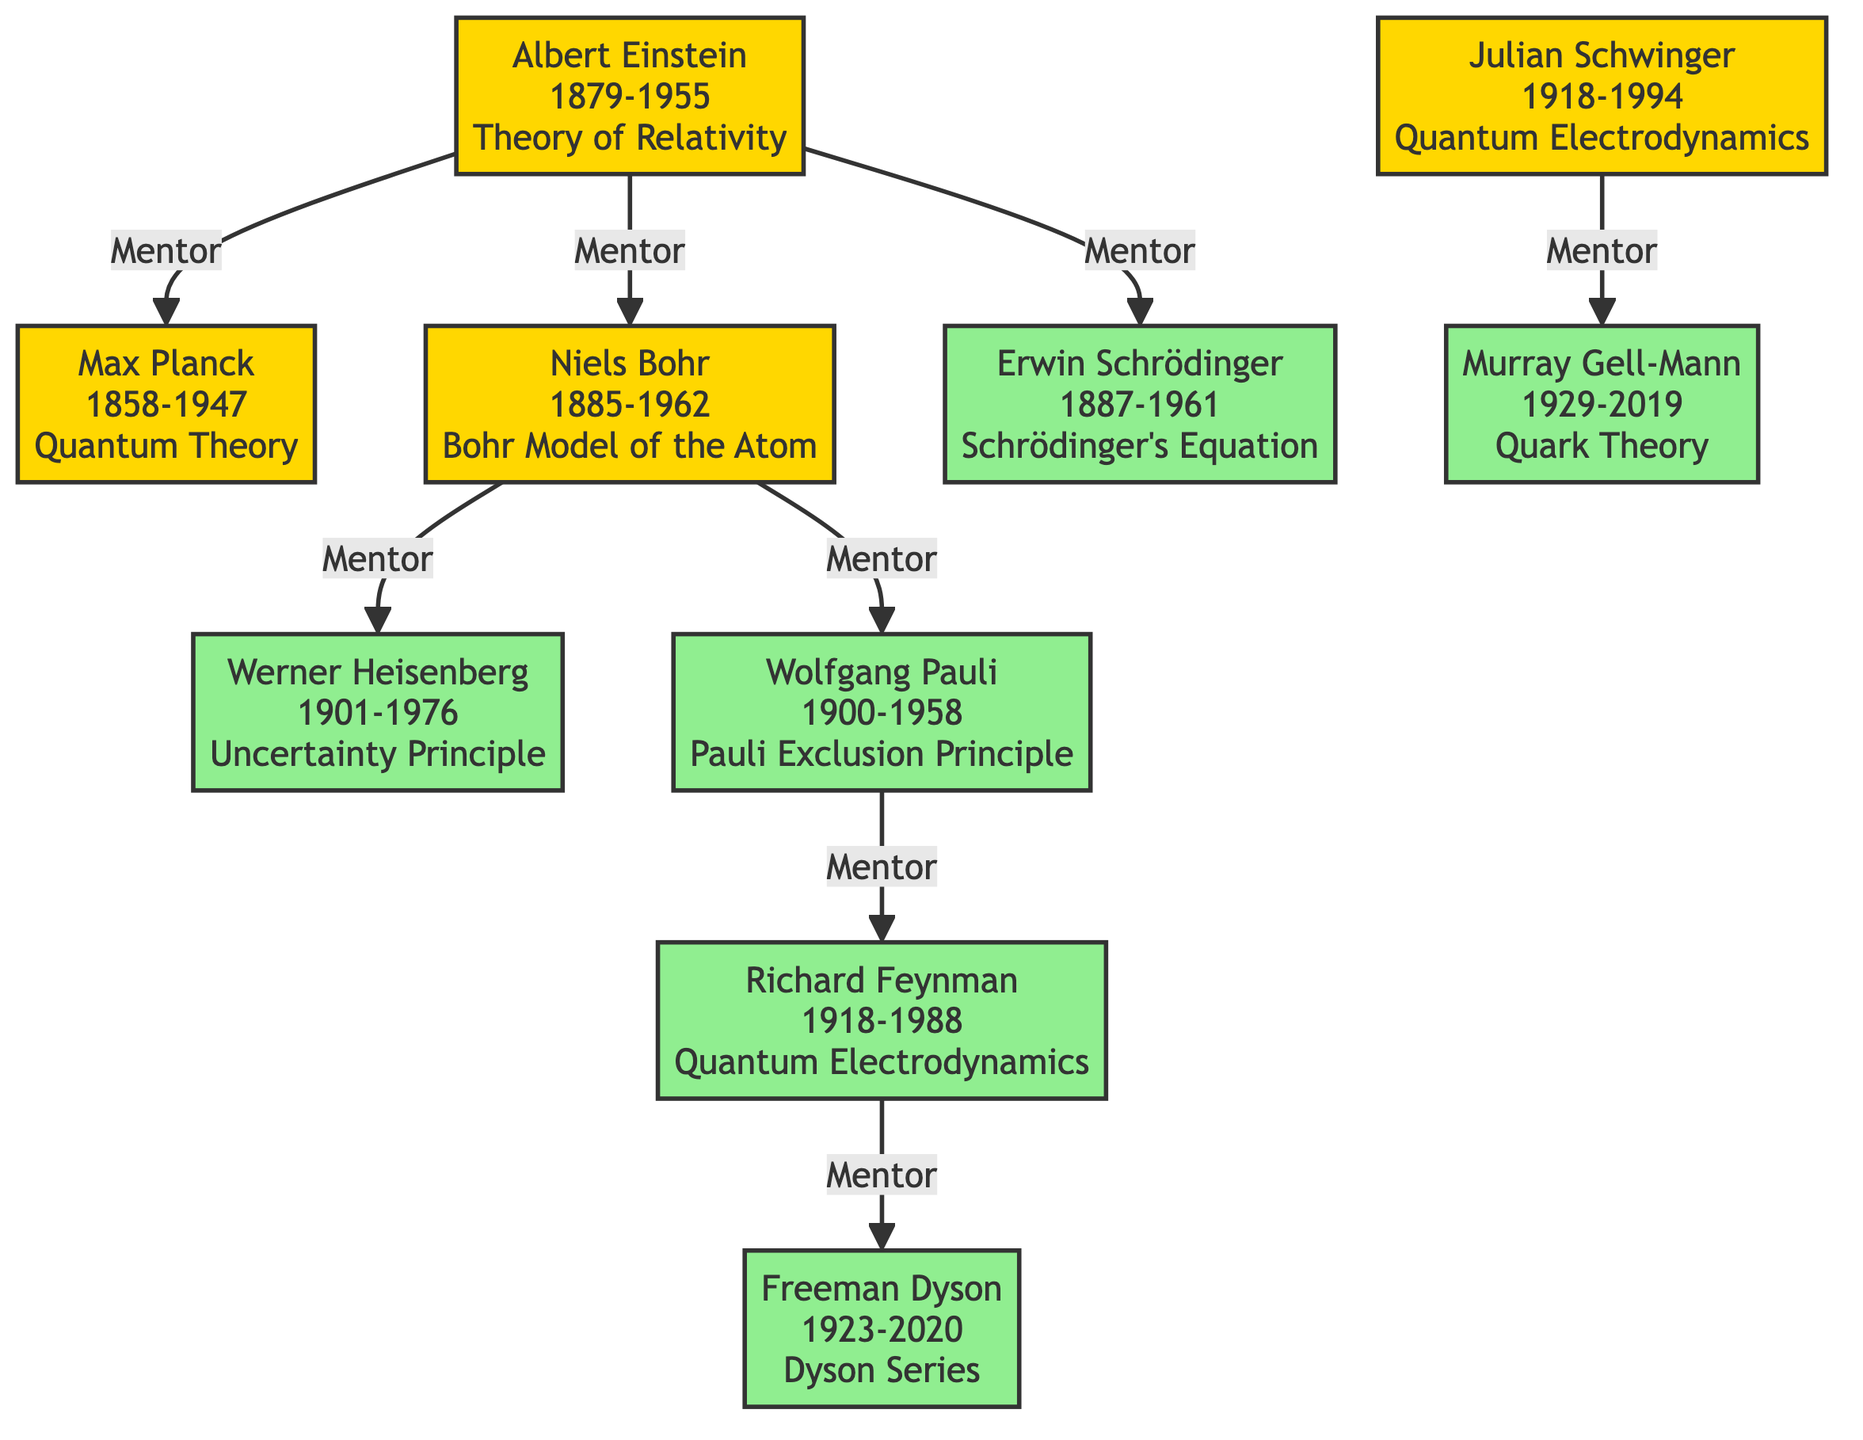What is Niels Bohr known for? According to the diagram, Niels Bohr is described as known for the "Bohr Model of the Atom."
Answer: Bohr Model of the Atom Who mentored Richard Feynman? The diagram indicates that Richard Feynman was mentored by Wolfgang Pauli.
Answer: Wolfgang Pauli How many protégés did Albert Einstein have? By examining the diagram, Albert Einstein is linked to three protégés: Erwin Schrödinger, Niels Bohr, and Max Planck.
Answer: 3 Which physicist is a protégé of both Niels Bohr and Wolfgang Pauli? The diagram shows that Wolfgang Pauli was a protégé of Niels Bohr and that Richard Feynman was mentored by Wolfgang Pauli; however, no single physicist fits both mentorships. Therefore, there is no answer.
Answer: None What is the relationship between Max Planck and Albert Einstein? The diagram illustrates that Max Planck was mentored by Albert Einstein.
Answer: Mentor Who mentored Murray Gell-Mann? As per the diagram, Murray Gell-Mann was mentored by Julian Schwinger.
Answer: Julian Schwinger Which two physicists are contemporaries in the timeline? When assessing the timelines displayed in the diagram, Julian Schwinger and Richard Feynman were both born in the same period (1918).
Answer: 1918 What significant concept did Wolfgang Pauli contribute to? According to the diagram, Wolfgang Pauli is known for the "Pauli Exclusion Principle."
Answer: Pauli Exclusion Principle Who are the mentors of Werner Heisenberg? The diagram reveals that Werner Heisenberg was mentored by Niels Bohr.
Answer: Niels Bohr 